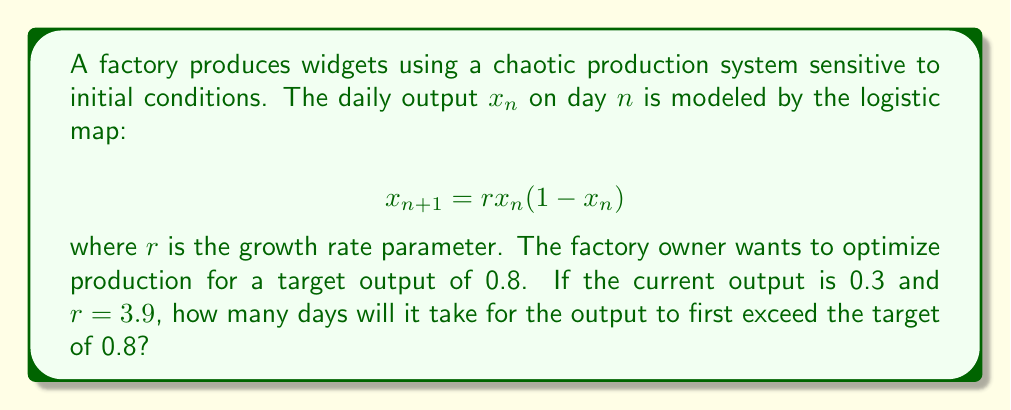Can you solve this math problem? To solve this problem, we need to iterate the logistic map equation until the output exceeds 0.8. Let's follow these steps:

1) Initial conditions: $x_0 = 0.3$, $r = 3.9$

2) Iterate the equation:

   Day 1: $x_1 = 3.9 \cdot 0.3 \cdot (1-0.3) = 0.819$

3) Check if $x_1 > 0.8$:
   $0.819 > 0.8$, so the condition is met on the first day.

This demonstrates the sensitivity to initial conditions in chaotic systems. A small change in the initial output or the growth rate parameter could lead to a significantly different number of days to reach the target.
Answer: 1 day 